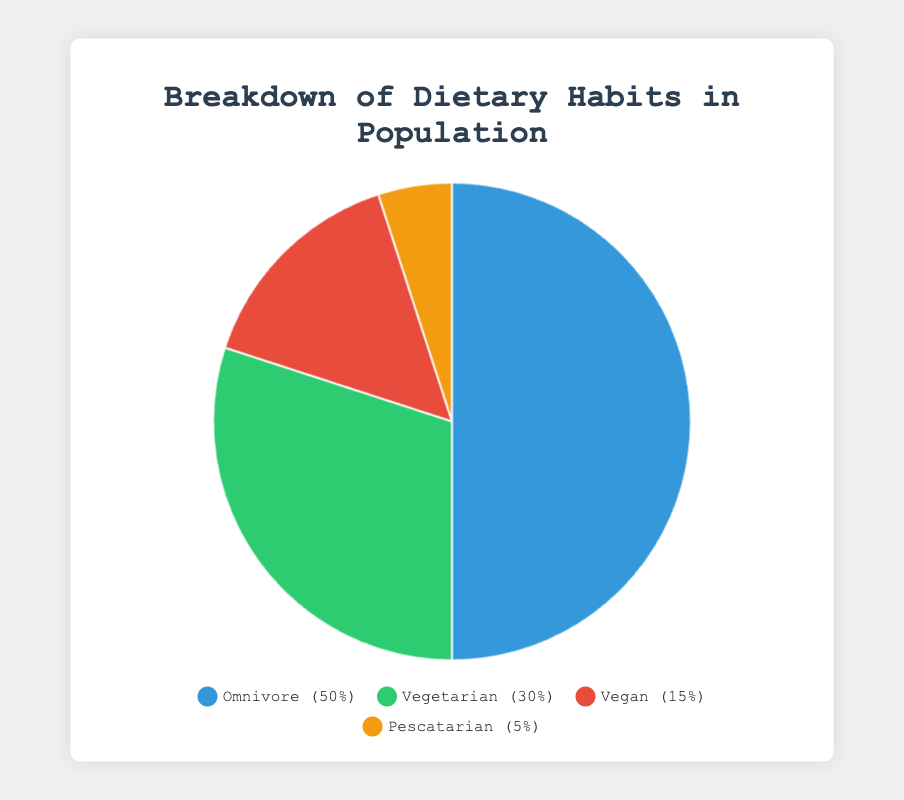What percentage of the population is either vegetarian or vegan? To find the percentage of the population that is either vegetarian or vegan, sum the percentages of the vegetarian and vegan groups: 30% (vegetarian) + 15% (vegan) = 45%.
Answer: 45% Which diet type has the highest average daily calorie intake? Compare the average daily calorie intake of each diet type: Omnivore (2200), Vegetarian (2000), Vegan (1800), Pescatarian (2100). Omnivore has the highest average daily calories.
Answer: Omnivore How many more calories does an omnivore consume daily compared to a vegan? Subtract the average daily calorie intake of a vegan from that of an omnivore: 2200 (Omnivore) - 1800 (Vegan) = 400. An omnivore consumes 400 more calories daily compared to a vegan.
Answer: 400 What is the combined percentage of the population that follows a diet including animal products (omnivore, pescatarian)? Sum the percentages of the omnivore and pescatarian groups: 50% (omnivore) + 5% (pescatarian) = 55%.
Answer: 55% Which dietary group has the lowest percentage in the population? Examine the percentages of each dietary group: Omnivore (50%), Vegetarian (30%), Vegan (15%), Pescatarian (5%). The Pescatarian group has the lowest percentage at 5%.
Answer: Pescatarian What percentage of the population follows a diet excluding all animal products? Sum the percentages of the vegan and vegetarian groups: 15% (vegan) + 30% (vegetarian) = 45%. Note that vegetarians may consume dairy, but they still do not consume meat.
Answer: 45% Compare the protein intake as a percentage of total nutrients consumed by vegetarians and pescatarians. Which group has a higher intake? Compare the protein intake percentages from the nutrient distribution data: Vegetarian (20%), Pescatarian (30%). Pescatarian has a higher protein intake.
Answer: Pescatarian Which group has the highest carbohydrate intake as a percentage of their total dietary intake? Compare the carbohydrate intake percentages from the nutrient distribution data of each group: Omnivore (50%), Vegetarian (60%), Vegan (65%), Pescatarian (50%). The Vegan group has the highest carbohydrate intake at 65%.
Answer: Vegan If we merge the vegetarian and pescatarian populations, what percentage of the total population will the new group represent? Sum the percentages of the vegetarian and pescatarian populations: 30% (Vegetarian) + 5% (Pescatarian) = 35%. The new group will represent 35% of the total population.
Answer: 35% 